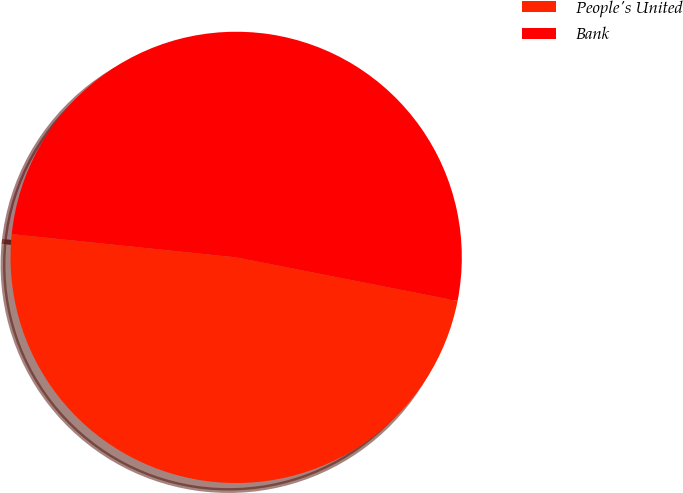<chart> <loc_0><loc_0><loc_500><loc_500><pie_chart><fcel>People's United<fcel>Bank<nl><fcel>48.55%<fcel>51.45%<nl></chart> 